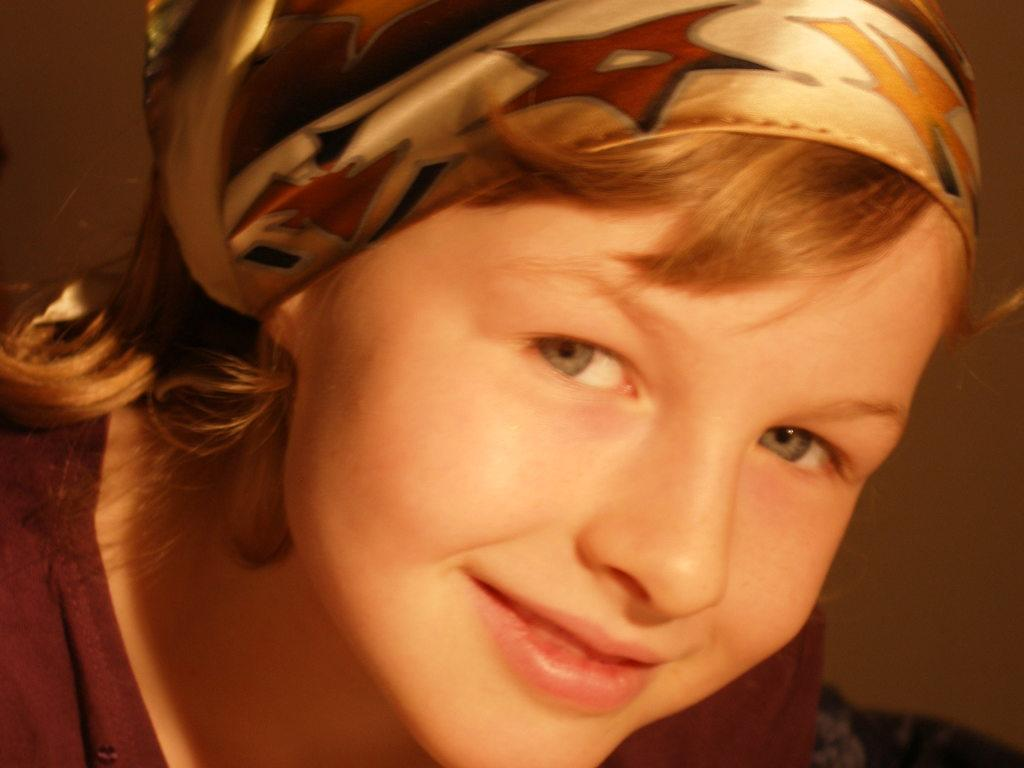Who is the main subject in the image? There is a woman in the image. What is the woman wearing? The woman is wearing a brown T-shirt. What expression does the woman have? The woman is smiling. What can be observed about the background of the image? The background of the image is dark in color. What type of toy is the woman holding in her mouth in the image? There is no toy present in the image, nor is the woman holding anything in her mouth. 